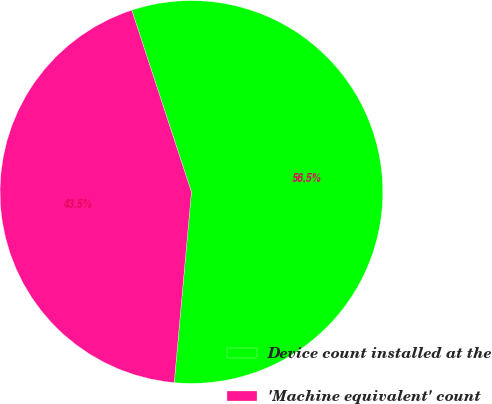Convert chart. <chart><loc_0><loc_0><loc_500><loc_500><pie_chart><fcel>Device count installed at the<fcel>'Machine equivalent' count<nl><fcel>56.48%<fcel>43.52%<nl></chart> 